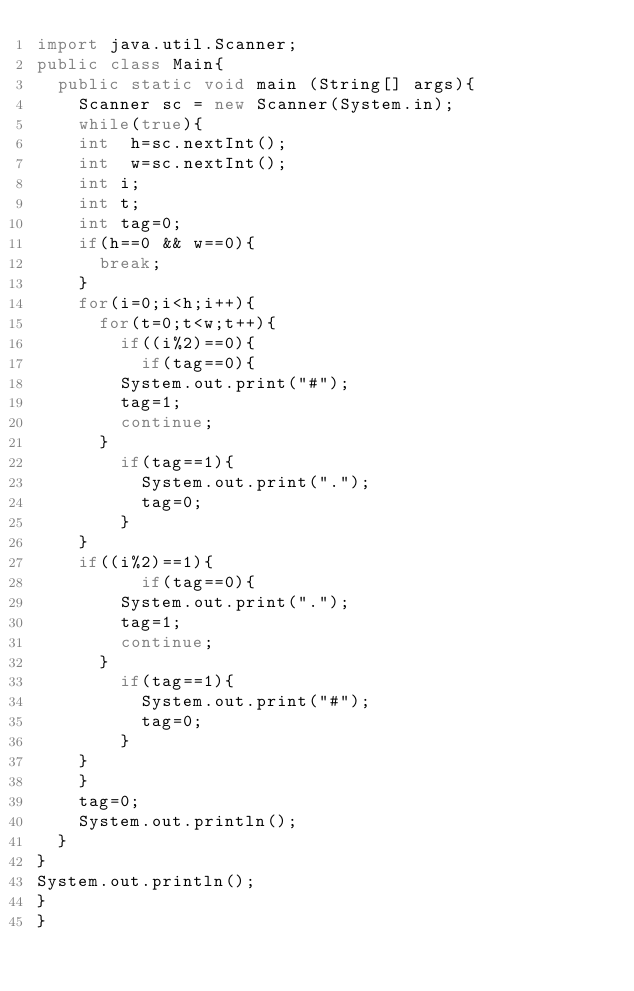Convert code to text. <code><loc_0><loc_0><loc_500><loc_500><_Java_>import java.util.Scanner;
public class Main{
	public static void main (String[] args){
		Scanner sc = new Scanner(System.in);
		while(true){
		int  h=sc.nextInt();
		int  w=sc.nextInt();
		int i;
		int t;
		int tag=0;
		if(h==0 && w==0){
			break;
		}
		for(i=0;i<h;i++){
			for(t=0;t<w;t++){
				if((i%2)==0){
					if(tag==0){
				System.out.print("#");
				tag=1;
				continue;
			}
				if(tag==1){
					System.out.print(".");
					tag=0;
				}
		}
		if((i%2)==1){
					if(tag==0){
				System.out.print(".");
				tag=1;
				continue;
			}
				if(tag==1){
					System.out.print("#");
					tag=0;
				}
		}
		}
		tag=0;
		System.out.println();
	}
}
System.out.println();
}
}</code> 